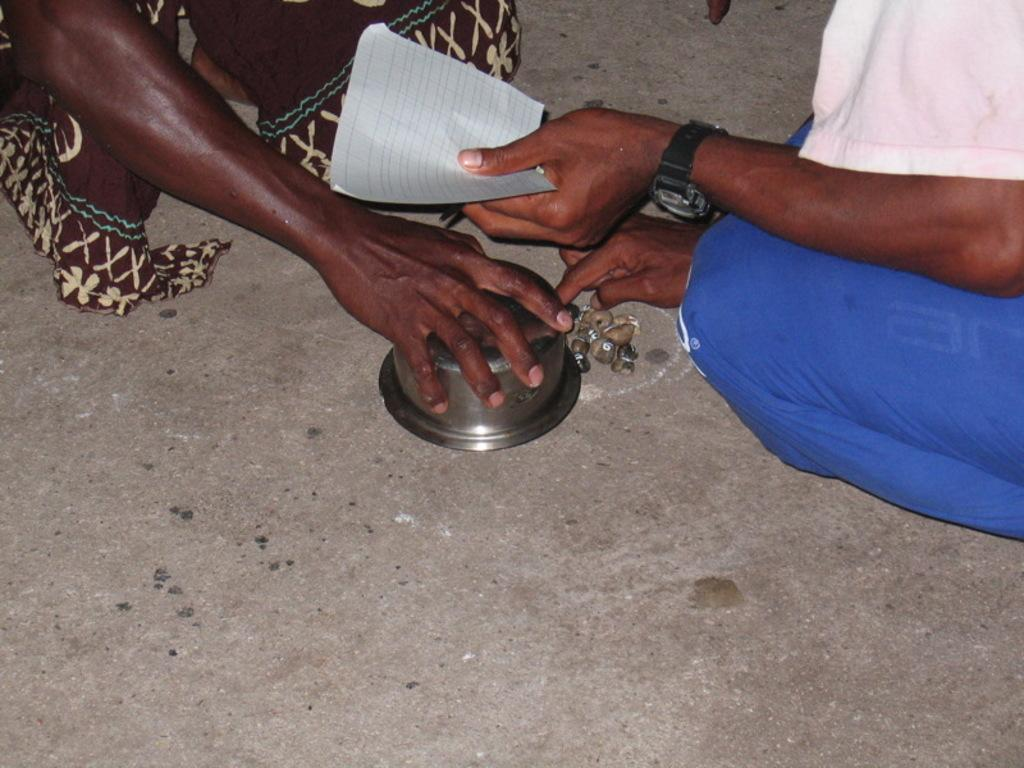How many people are in the image? There are two persons in the image. Can you describe the clothing of the person on the right? The person on the right is wearing a white and blue color dress. What object can be seen in the image besides the two persons? There is a bowl in the image. What is the color of the paper in the image? The paper in the image is white in color. What type of earth is visible in the image? There is no earth visible in the image; it is an image of two persons and a bowl. What nation are the persons in the image from? The facts provided do not give any information about the nationality of the persons in the image. 